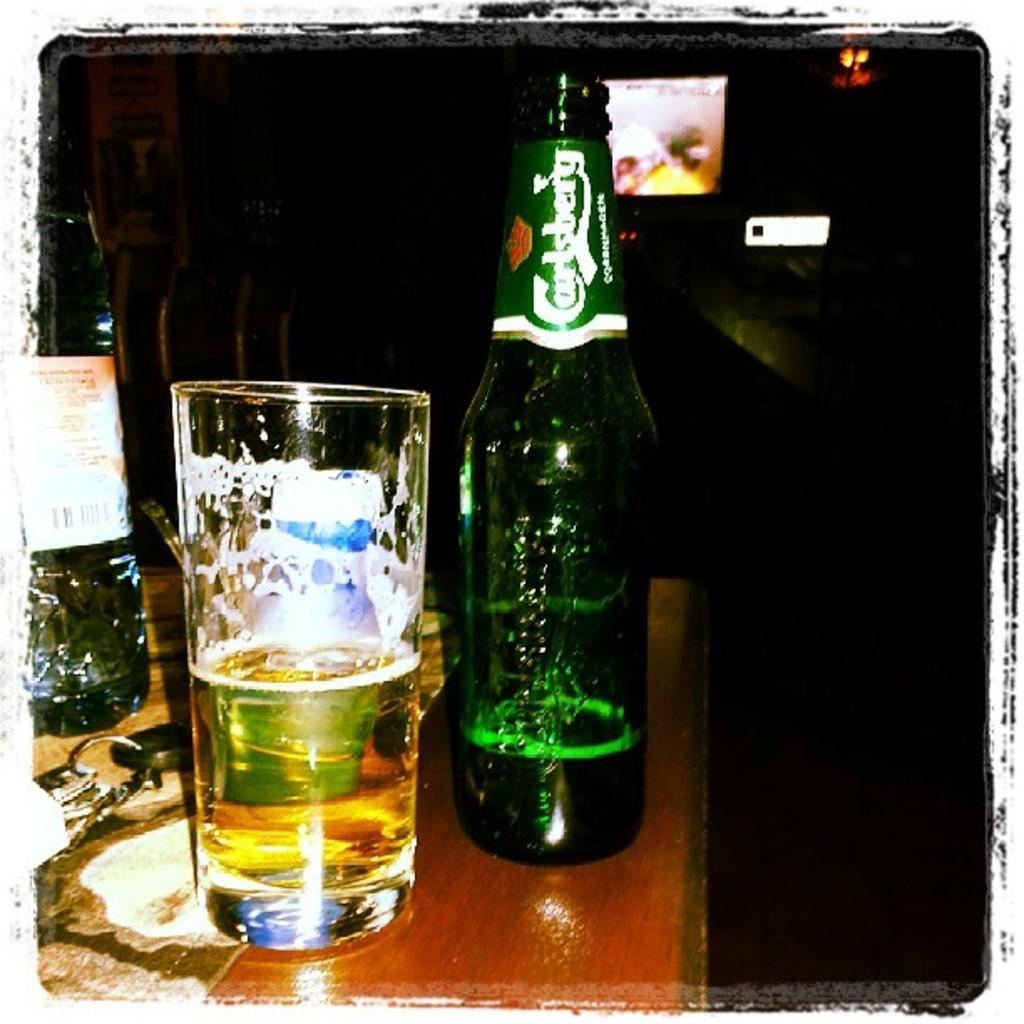What objects are on the table in the image? There is a bottle, a glass, and a keychain on the table in the image. Can you describe the screen visible in the background? Unfortunately, the facts provided do not give any information about the screen, so it cannot be described. What might be used for drinking in the image? The glass on the table might be used for drinking. What type of bun is being used to hold the cheese in the image? There is no bun or cheese present in the image. What is the keychain writing in the image? The keychain does not have any writing on it, and there is no writing mentioned in the provided facts. 